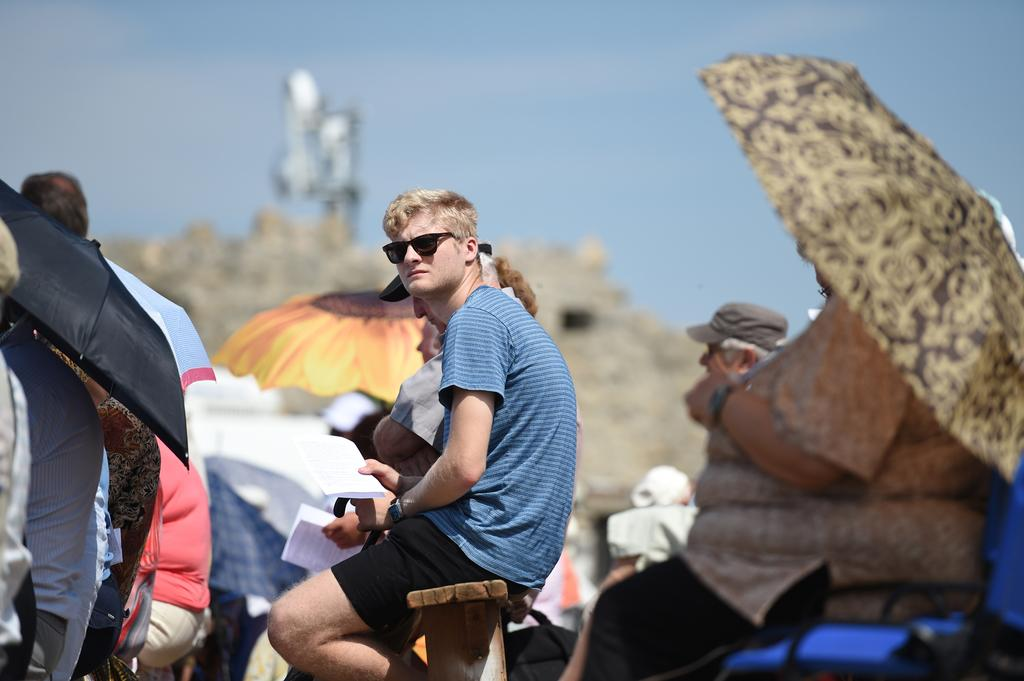What are the people in the center of the image doing? There are people sitting in the center of the image. What are some of the people holding? Some of the people are holding umbrellas. What is the man in the center holding? The man sitting in the center is holding papers. What can be seen in the background of the image? There is sky visible in the background of the image. Can you see any instances of people kissing on the edge of the image? There is no mention of kissing or an edge in the image, so it cannot be determined from the provided facts. 